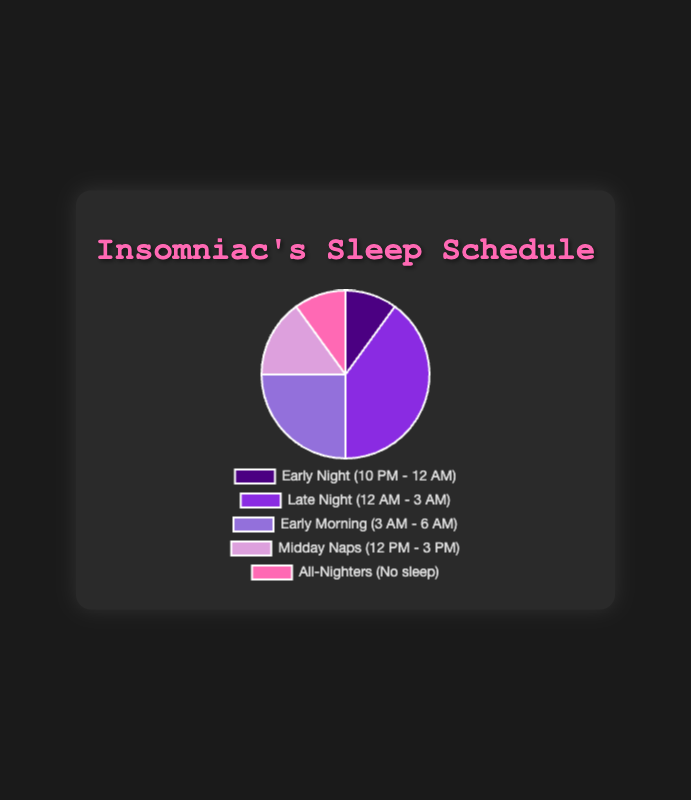What's the largest sleep segment in the schedule? From observing the pie chart, the segment labeled 'Late Night (12 AM - 3 AM)' dominates the chart visually, suggesting it has the highest value.
Answer: Late Night (12 AM - 3 AM) Which segments combine to make up half of the sleep schedule? According to the data, the segments 'Late Night (12 AM - 3 AM)' and 'Early Morning (3 AM - 6 AM)' together make up 40% + 25% = 65%, exceeding half of the sleep schedule. Thus, you need only the largest one and part of the next to reach or exceed half.
Answer: Late Night (12 AM - 3 AM) and Early Morning (3 AM - 6 AM) What is the total percentage for 'Midday Naps (12 PM - 3 PM)' and 'All-Nighters (No sleep)' combined? The pie chart shows 'Midday Naps (12 PM - 3 PM)' as 15% and 'All-Nighters (No sleep)' as 10%. Adding these values gives 15% + 10% = 25%.
Answer: 25% Is the share of 'Early Morning (3 AM - 6 AM)' greater than 'Early Night (10 PM - 12 AM)'? The data indicates 'Early Morning (3 AM - 6 AM)' is 25%, while 'Early Night (10 PM - 12 AM)' is 10%. Since 25% is greater than 10%, the share of 'Early Morning' is indeed greater.
Answer: Yes What percentage of sleep falls outside standard nighttime hours (10 PM - 6 AM)? Sleep outside 'Early Night (10 PM - 12 AM)' and 'Late Night (12 AM - 3 AM)' includes 'Midday Naps (12 PM - 3 PM)' and 'All-Nighters (No sleep)', which total 15% + 10% = 25%. 'Early Morning (3 AM - 6 AM)' is also nighttime hours, hence not counted here.
Answer: 25% Which sleep segment has the second-highest percentage? Observing the pie chart, 'Early Morning (3 AM - 6 AM)' is the second largest segment after 'Late Night (12 AM - 3 AM)' with 25% of the schedule.
Answer: Early Morning (3 AM - 6 AM) How do 'Late Night (12 AM - 3 AM)' and 'All-Nighters (No sleep)' compare proportionally? From the data, 'Late Night (12 AM - 3 AM)' accounts for 40% and 'All-Nighters (No sleep)' accounts for 10%. Comparing these, 'Late Night' is four times larger than 'All-Nighters'.
Answer: Four times larger What percentage does 'Early Night (10 PM - 12 AM)' and 'All-Nighters (No sleep)' together represent? Adding the two percentages from the data: 'Early Night (10 PM - 12 AM)' is 10% and 'All-Nighters (No sleep)' is also 10%. Total combined is 10% + 10% = 20%.
Answer: 20% What color represents 'Late Night (12 AM - 3 AM)'? By looking at the colors used in the pie chart, 'Late Night (12 AM - 3 AM)' is represented by a purple shade.
Answer: Purple 